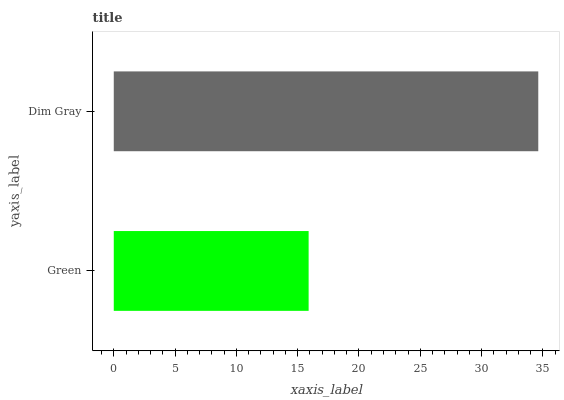Is Green the minimum?
Answer yes or no. Yes. Is Dim Gray the maximum?
Answer yes or no. Yes. Is Dim Gray the minimum?
Answer yes or no. No. Is Dim Gray greater than Green?
Answer yes or no. Yes. Is Green less than Dim Gray?
Answer yes or no. Yes. Is Green greater than Dim Gray?
Answer yes or no. No. Is Dim Gray less than Green?
Answer yes or no. No. Is Dim Gray the high median?
Answer yes or no. Yes. Is Green the low median?
Answer yes or no. Yes. Is Green the high median?
Answer yes or no. No. Is Dim Gray the low median?
Answer yes or no. No. 